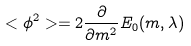Convert formula to latex. <formula><loc_0><loc_0><loc_500><loc_500>< \phi ^ { 2 } > = 2 \frac { \partial } { \partial m ^ { 2 } } E _ { 0 } ( m , \lambda )</formula> 